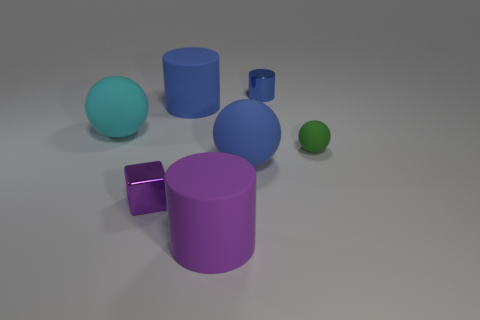The other matte thing that is the same shape as the large purple matte object is what color?
Your answer should be very brief. Blue. What is the color of the rubber ball that is the same size as the cyan object?
Keep it short and to the point. Blue. Is the blue ball made of the same material as the tiny block?
Keep it short and to the point. No. What number of tiny cylinders have the same color as the small block?
Your answer should be very brief. 0. What material is the large cylinder behind the blue ball?
Provide a succinct answer. Rubber. What number of tiny things are cyan balls or purple matte cylinders?
Give a very brief answer. 0. There is a large cylinder that is the same color as the block; what is its material?
Give a very brief answer. Rubber. Is there a big cylinder that has the same material as the big cyan object?
Offer a very short reply. Yes. Is the size of the green matte object that is right of the cyan matte sphere the same as the tiny shiny cylinder?
Offer a terse response. Yes. There is a rubber sphere left of the metallic thing that is in front of the cyan matte thing; are there any objects behind it?
Ensure brevity in your answer.  Yes. 